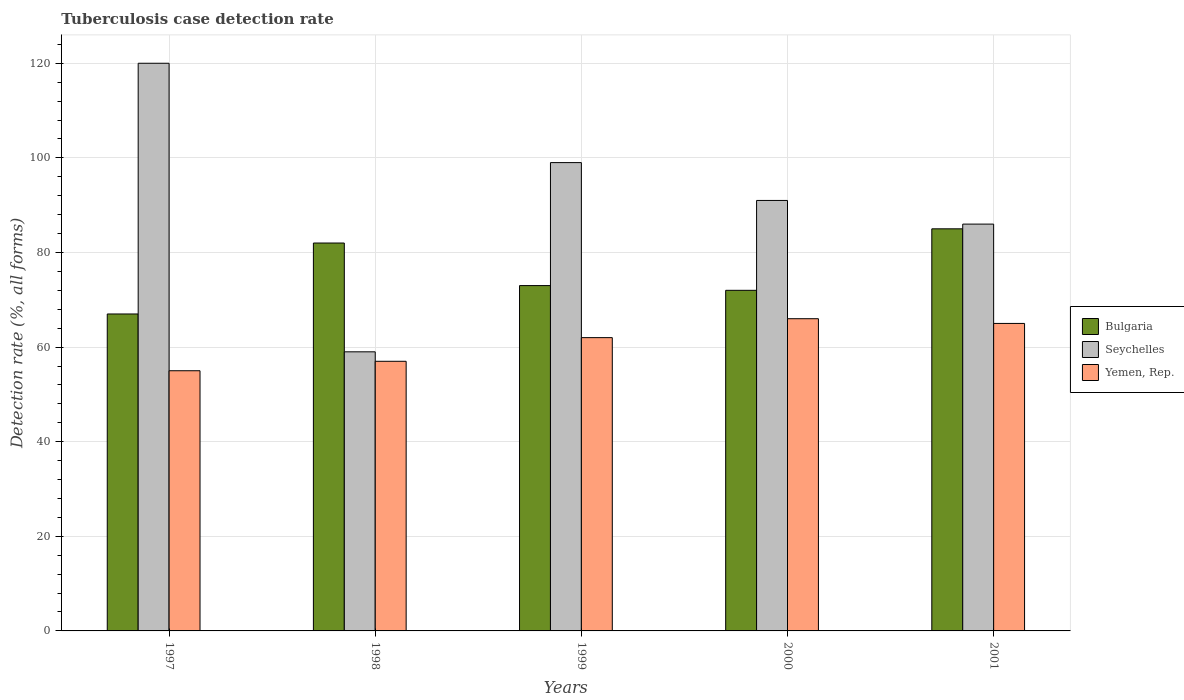How many different coloured bars are there?
Your response must be concise. 3. Are the number of bars per tick equal to the number of legend labels?
Provide a succinct answer. Yes. How many bars are there on the 3rd tick from the left?
Keep it short and to the point. 3. How many bars are there on the 2nd tick from the right?
Offer a terse response. 3. What is the label of the 5th group of bars from the left?
Your answer should be very brief. 2001. In how many cases, is the number of bars for a given year not equal to the number of legend labels?
Make the answer very short. 0. What is the tuberculosis case detection rate in in Yemen, Rep. in 2001?
Provide a succinct answer. 65. Across all years, what is the maximum tuberculosis case detection rate in in Bulgaria?
Keep it short and to the point. 85. Across all years, what is the minimum tuberculosis case detection rate in in Bulgaria?
Your response must be concise. 67. What is the total tuberculosis case detection rate in in Bulgaria in the graph?
Ensure brevity in your answer.  379. What is the difference between the tuberculosis case detection rate in in Yemen, Rep. in 1997 and that in 1998?
Your answer should be compact. -2. What is the difference between the tuberculosis case detection rate in in Bulgaria in 1997 and the tuberculosis case detection rate in in Yemen, Rep. in 1999?
Your answer should be compact. 5. What is the average tuberculosis case detection rate in in Bulgaria per year?
Your answer should be very brief. 75.8. In the year 2000, what is the difference between the tuberculosis case detection rate in in Seychelles and tuberculosis case detection rate in in Yemen, Rep.?
Give a very brief answer. 25. In how many years, is the tuberculosis case detection rate in in Seychelles greater than 24 %?
Make the answer very short. 5. What is the ratio of the tuberculosis case detection rate in in Bulgaria in 1997 to that in 2001?
Give a very brief answer. 0.79. What is the difference between the highest and the lowest tuberculosis case detection rate in in Bulgaria?
Keep it short and to the point. 18. In how many years, is the tuberculosis case detection rate in in Bulgaria greater than the average tuberculosis case detection rate in in Bulgaria taken over all years?
Give a very brief answer. 2. What does the 3rd bar from the left in 1997 represents?
Provide a succinct answer. Yemen, Rep. What does the 1st bar from the right in 1997 represents?
Ensure brevity in your answer.  Yemen, Rep. How many years are there in the graph?
Offer a very short reply. 5. What is the difference between two consecutive major ticks on the Y-axis?
Ensure brevity in your answer.  20. Are the values on the major ticks of Y-axis written in scientific E-notation?
Keep it short and to the point. No. Does the graph contain any zero values?
Your answer should be compact. No. Where does the legend appear in the graph?
Make the answer very short. Center right. How many legend labels are there?
Keep it short and to the point. 3. What is the title of the graph?
Provide a succinct answer. Tuberculosis case detection rate. Does "Marshall Islands" appear as one of the legend labels in the graph?
Your answer should be compact. No. What is the label or title of the Y-axis?
Offer a very short reply. Detection rate (%, all forms). What is the Detection rate (%, all forms) of Seychelles in 1997?
Your answer should be compact. 120. What is the Detection rate (%, all forms) of Yemen, Rep. in 1997?
Offer a terse response. 55. What is the Detection rate (%, all forms) in Bulgaria in 1998?
Offer a terse response. 82. What is the Detection rate (%, all forms) in Seychelles in 1998?
Your answer should be compact. 59. What is the Detection rate (%, all forms) in Bulgaria in 1999?
Your response must be concise. 73. What is the Detection rate (%, all forms) of Bulgaria in 2000?
Your answer should be compact. 72. What is the Detection rate (%, all forms) of Seychelles in 2000?
Provide a succinct answer. 91. What is the Detection rate (%, all forms) of Bulgaria in 2001?
Your response must be concise. 85. Across all years, what is the maximum Detection rate (%, all forms) in Seychelles?
Your answer should be compact. 120. What is the total Detection rate (%, all forms) in Bulgaria in the graph?
Your answer should be very brief. 379. What is the total Detection rate (%, all forms) in Seychelles in the graph?
Provide a short and direct response. 455. What is the total Detection rate (%, all forms) in Yemen, Rep. in the graph?
Give a very brief answer. 305. What is the difference between the Detection rate (%, all forms) of Bulgaria in 1997 and that in 1998?
Your response must be concise. -15. What is the difference between the Detection rate (%, all forms) in Seychelles in 1997 and that in 1998?
Provide a succinct answer. 61. What is the difference between the Detection rate (%, all forms) in Yemen, Rep. in 1997 and that in 1998?
Your response must be concise. -2. What is the difference between the Detection rate (%, all forms) in Bulgaria in 1997 and that in 1999?
Keep it short and to the point. -6. What is the difference between the Detection rate (%, all forms) in Yemen, Rep. in 1997 and that in 1999?
Ensure brevity in your answer.  -7. What is the difference between the Detection rate (%, all forms) of Bulgaria in 1997 and that in 2000?
Offer a very short reply. -5. What is the difference between the Detection rate (%, all forms) of Seychelles in 1997 and that in 2000?
Your answer should be very brief. 29. What is the difference between the Detection rate (%, all forms) in Yemen, Rep. in 1997 and that in 2000?
Your answer should be compact. -11. What is the difference between the Detection rate (%, all forms) of Seychelles in 1997 and that in 2001?
Provide a succinct answer. 34. What is the difference between the Detection rate (%, all forms) in Yemen, Rep. in 1997 and that in 2001?
Offer a terse response. -10. What is the difference between the Detection rate (%, all forms) of Bulgaria in 1998 and that in 1999?
Your response must be concise. 9. What is the difference between the Detection rate (%, all forms) of Bulgaria in 1998 and that in 2000?
Provide a short and direct response. 10. What is the difference between the Detection rate (%, all forms) in Seychelles in 1998 and that in 2000?
Make the answer very short. -32. What is the difference between the Detection rate (%, all forms) of Yemen, Rep. in 1998 and that in 2000?
Your response must be concise. -9. What is the difference between the Detection rate (%, all forms) in Seychelles in 1998 and that in 2001?
Your response must be concise. -27. What is the difference between the Detection rate (%, all forms) in Bulgaria in 1999 and that in 2000?
Keep it short and to the point. 1. What is the difference between the Detection rate (%, all forms) in Seychelles in 1999 and that in 2000?
Provide a succinct answer. 8. What is the difference between the Detection rate (%, all forms) in Yemen, Rep. in 1999 and that in 2000?
Keep it short and to the point. -4. What is the difference between the Detection rate (%, all forms) in Seychelles in 1999 and that in 2001?
Provide a short and direct response. 13. What is the difference between the Detection rate (%, all forms) in Seychelles in 2000 and that in 2001?
Provide a succinct answer. 5. What is the difference between the Detection rate (%, all forms) of Bulgaria in 1997 and the Detection rate (%, all forms) of Yemen, Rep. in 1998?
Give a very brief answer. 10. What is the difference between the Detection rate (%, all forms) in Bulgaria in 1997 and the Detection rate (%, all forms) in Seychelles in 1999?
Keep it short and to the point. -32. What is the difference between the Detection rate (%, all forms) in Seychelles in 1997 and the Detection rate (%, all forms) in Yemen, Rep. in 1999?
Provide a succinct answer. 58. What is the difference between the Detection rate (%, all forms) of Bulgaria in 1997 and the Detection rate (%, all forms) of Yemen, Rep. in 2000?
Ensure brevity in your answer.  1. What is the difference between the Detection rate (%, all forms) in Seychelles in 1997 and the Detection rate (%, all forms) in Yemen, Rep. in 2000?
Offer a very short reply. 54. What is the difference between the Detection rate (%, all forms) in Bulgaria in 1997 and the Detection rate (%, all forms) in Yemen, Rep. in 2001?
Your answer should be very brief. 2. What is the difference between the Detection rate (%, all forms) in Seychelles in 1997 and the Detection rate (%, all forms) in Yemen, Rep. in 2001?
Offer a very short reply. 55. What is the difference between the Detection rate (%, all forms) in Bulgaria in 1998 and the Detection rate (%, all forms) in Seychelles in 1999?
Provide a succinct answer. -17. What is the difference between the Detection rate (%, all forms) of Bulgaria in 1998 and the Detection rate (%, all forms) of Seychelles in 2000?
Your answer should be very brief. -9. What is the difference between the Detection rate (%, all forms) of Bulgaria in 1998 and the Detection rate (%, all forms) of Yemen, Rep. in 2000?
Provide a succinct answer. 16. What is the difference between the Detection rate (%, all forms) of Seychelles in 1998 and the Detection rate (%, all forms) of Yemen, Rep. in 2000?
Your answer should be compact. -7. What is the difference between the Detection rate (%, all forms) in Bulgaria in 1998 and the Detection rate (%, all forms) in Yemen, Rep. in 2001?
Give a very brief answer. 17. What is the difference between the Detection rate (%, all forms) of Seychelles in 1998 and the Detection rate (%, all forms) of Yemen, Rep. in 2001?
Your answer should be compact. -6. What is the difference between the Detection rate (%, all forms) in Bulgaria in 1999 and the Detection rate (%, all forms) in Seychelles in 2000?
Your answer should be very brief. -18. What is the difference between the Detection rate (%, all forms) in Bulgaria in 1999 and the Detection rate (%, all forms) in Yemen, Rep. in 2000?
Your answer should be very brief. 7. What is the difference between the Detection rate (%, all forms) in Seychelles in 1999 and the Detection rate (%, all forms) in Yemen, Rep. in 2000?
Give a very brief answer. 33. What is the difference between the Detection rate (%, all forms) of Bulgaria in 1999 and the Detection rate (%, all forms) of Yemen, Rep. in 2001?
Provide a short and direct response. 8. What is the difference between the Detection rate (%, all forms) of Seychelles in 1999 and the Detection rate (%, all forms) of Yemen, Rep. in 2001?
Your answer should be very brief. 34. What is the difference between the Detection rate (%, all forms) in Bulgaria in 2000 and the Detection rate (%, all forms) in Yemen, Rep. in 2001?
Provide a succinct answer. 7. What is the difference between the Detection rate (%, all forms) in Seychelles in 2000 and the Detection rate (%, all forms) in Yemen, Rep. in 2001?
Your response must be concise. 26. What is the average Detection rate (%, all forms) of Bulgaria per year?
Offer a terse response. 75.8. What is the average Detection rate (%, all forms) in Seychelles per year?
Keep it short and to the point. 91. What is the average Detection rate (%, all forms) in Yemen, Rep. per year?
Give a very brief answer. 61. In the year 1997, what is the difference between the Detection rate (%, all forms) of Bulgaria and Detection rate (%, all forms) of Seychelles?
Your response must be concise. -53. In the year 1997, what is the difference between the Detection rate (%, all forms) of Bulgaria and Detection rate (%, all forms) of Yemen, Rep.?
Your answer should be compact. 12. In the year 1998, what is the difference between the Detection rate (%, all forms) of Seychelles and Detection rate (%, all forms) of Yemen, Rep.?
Ensure brevity in your answer.  2. In the year 1999, what is the difference between the Detection rate (%, all forms) of Seychelles and Detection rate (%, all forms) of Yemen, Rep.?
Keep it short and to the point. 37. In the year 2000, what is the difference between the Detection rate (%, all forms) in Bulgaria and Detection rate (%, all forms) in Seychelles?
Make the answer very short. -19. In the year 2000, what is the difference between the Detection rate (%, all forms) of Bulgaria and Detection rate (%, all forms) of Yemen, Rep.?
Your response must be concise. 6. In the year 2000, what is the difference between the Detection rate (%, all forms) of Seychelles and Detection rate (%, all forms) of Yemen, Rep.?
Offer a terse response. 25. In the year 2001, what is the difference between the Detection rate (%, all forms) in Bulgaria and Detection rate (%, all forms) in Yemen, Rep.?
Give a very brief answer. 20. In the year 2001, what is the difference between the Detection rate (%, all forms) of Seychelles and Detection rate (%, all forms) of Yemen, Rep.?
Your answer should be very brief. 21. What is the ratio of the Detection rate (%, all forms) of Bulgaria in 1997 to that in 1998?
Your response must be concise. 0.82. What is the ratio of the Detection rate (%, all forms) of Seychelles in 1997 to that in 1998?
Provide a succinct answer. 2.03. What is the ratio of the Detection rate (%, all forms) in Yemen, Rep. in 1997 to that in 1998?
Your answer should be very brief. 0.96. What is the ratio of the Detection rate (%, all forms) of Bulgaria in 1997 to that in 1999?
Provide a succinct answer. 0.92. What is the ratio of the Detection rate (%, all forms) in Seychelles in 1997 to that in 1999?
Your response must be concise. 1.21. What is the ratio of the Detection rate (%, all forms) of Yemen, Rep. in 1997 to that in 1999?
Your answer should be compact. 0.89. What is the ratio of the Detection rate (%, all forms) of Bulgaria in 1997 to that in 2000?
Give a very brief answer. 0.93. What is the ratio of the Detection rate (%, all forms) in Seychelles in 1997 to that in 2000?
Keep it short and to the point. 1.32. What is the ratio of the Detection rate (%, all forms) in Bulgaria in 1997 to that in 2001?
Offer a very short reply. 0.79. What is the ratio of the Detection rate (%, all forms) of Seychelles in 1997 to that in 2001?
Offer a very short reply. 1.4. What is the ratio of the Detection rate (%, all forms) of Yemen, Rep. in 1997 to that in 2001?
Your answer should be very brief. 0.85. What is the ratio of the Detection rate (%, all forms) in Bulgaria in 1998 to that in 1999?
Provide a succinct answer. 1.12. What is the ratio of the Detection rate (%, all forms) of Seychelles in 1998 to that in 1999?
Your answer should be compact. 0.6. What is the ratio of the Detection rate (%, all forms) in Yemen, Rep. in 1998 to that in 1999?
Provide a short and direct response. 0.92. What is the ratio of the Detection rate (%, all forms) in Bulgaria in 1998 to that in 2000?
Provide a short and direct response. 1.14. What is the ratio of the Detection rate (%, all forms) in Seychelles in 1998 to that in 2000?
Provide a succinct answer. 0.65. What is the ratio of the Detection rate (%, all forms) of Yemen, Rep. in 1998 to that in 2000?
Make the answer very short. 0.86. What is the ratio of the Detection rate (%, all forms) of Bulgaria in 1998 to that in 2001?
Keep it short and to the point. 0.96. What is the ratio of the Detection rate (%, all forms) of Seychelles in 1998 to that in 2001?
Make the answer very short. 0.69. What is the ratio of the Detection rate (%, all forms) in Yemen, Rep. in 1998 to that in 2001?
Ensure brevity in your answer.  0.88. What is the ratio of the Detection rate (%, all forms) in Bulgaria in 1999 to that in 2000?
Ensure brevity in your answer.  1.01. What is the ratio of the Detection rate (%, all forms) of Seychelles in 1999 to that in 2000?
Your answer should be very brief. 1.09. What is the ratio of the Detection rate (%, all forms) of Yemen, Rep. in 1999 to that in 2000?
Keep it short and to the point. 0.94. What is the ratio of the Detection rate (%, all forms) in Bulgaria in 1999 to that in 2001?
Provide a succinct answer. 0.86. What is the ratio of the Detection rate (%, all forms) of Seychelles in 1999 to that in 2001?
Offer a very short reply. 1.15. What is the ratio of the Detection rate (%, all forms) of Yemen, Rep. in 1999 to that in 2001?
Ensure brevity in your answer.  0.95. What is the ratio of the Detection rate (%, all forms) of Bulgaria in 2000 to that in 2001?
Keep it short and to the point. 0.85. What is the ratio of the Detection rate (%, all forms) in Seychelles in 2000 to that in 2001?
Make the answer very short. 1.06. What is the ratio of the Detection rate (%, all forms) of Yemen, Rep. in 2000 to that in 2001?
Your answer should be very brief. 1.02. What is the difference between the highest and the second highest Detection rate (%, all forms) of Bulgaria?
Offer a very short reply. 3. What is the difference between the highest and the second highest Detection rate (%, all forms) in Seychelles?
Ensure brevity in your answer.  21. What is the difference between the highest and the lowest Detection rate (%, all forms) in Bulgaria?
Your answer should be very brief. 18. What is the difference between the highest and the lowest Detection rate (%, all forms) in Yemen, Rep.?
Provide a short and direct response. 11. 